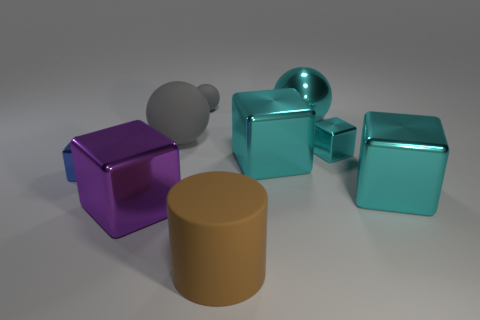There is a blue metal object that is the same shape as the big purple thing; what size is it? The small blue metal object appears to be a miniature version of the large purple cube, likely intended as a scaled-down replica. 